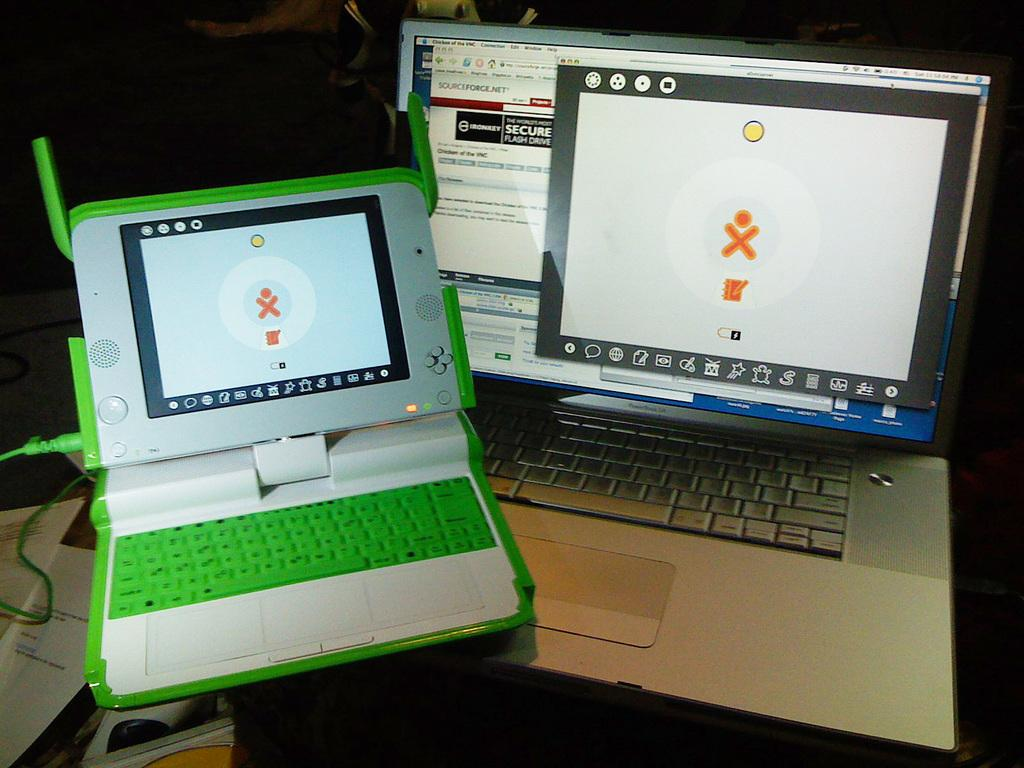Provide a one-sentence caption for the provided image. Two laptops, one of which has the words sourceforge.net at the top. 